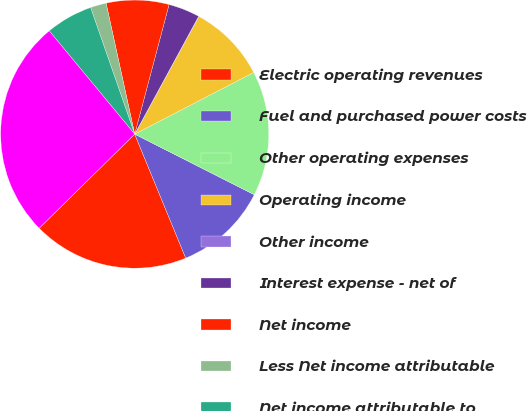Convert chart. <chart><loc_0><loc_0><loc_500><loc_500><pie_chart><fcel>Electric operating revenues<fcel>Fuel and purchased power costs<fcel>Other operating expenses<fcel>Operating income<fcel>Other income<fcel>Interest expense - net of<fcel>Net income<fcel>Less Net income attributable<fcel>Net income attributable to<fcel>Total assets<nl><fcel>18.84%<fcel>11.32%<fcel>15.08%<fcel>9.44%<fcel>0.03%<fcel>3.79%<fcel>7.55%<fcel>1.91%<fcel>5.67%<fcel>26.37%<nl></chart> 